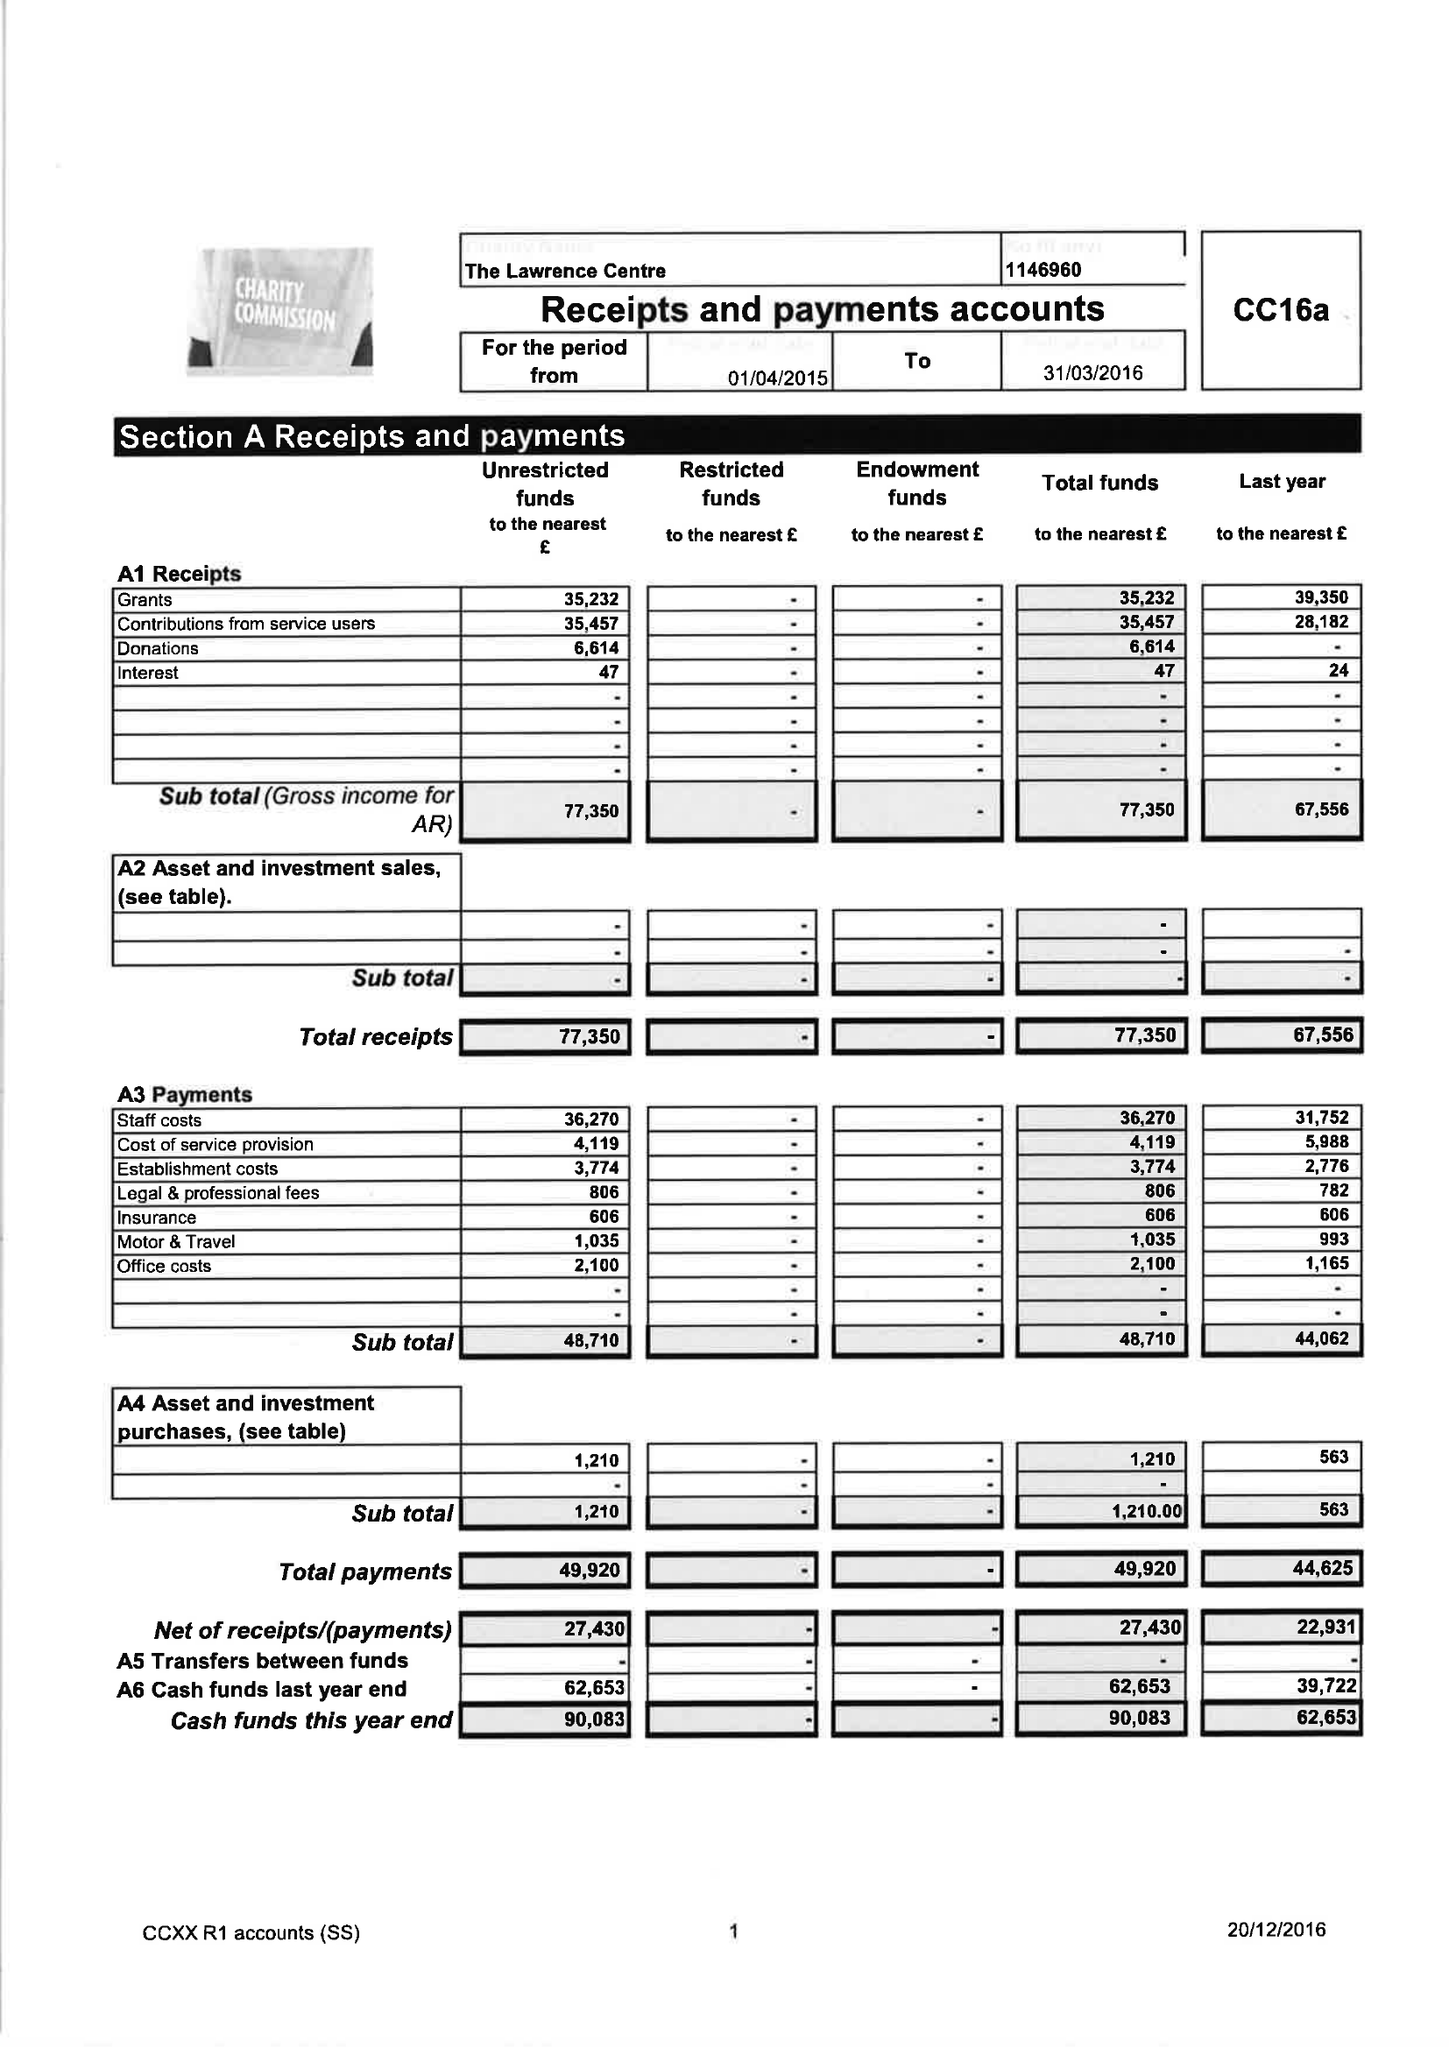What is the value for the charity_number?
Answer the question using a single word or phrase. 1146960 